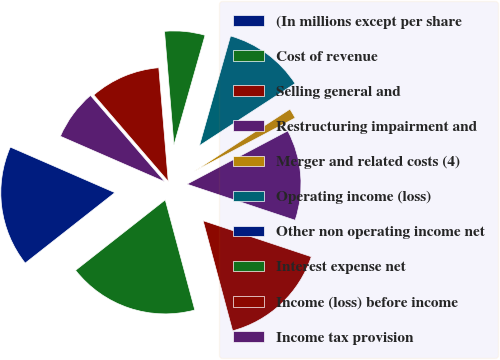Convert chart. <chart><loc_0><loc_0><loc_500><loc_500><pie_chart><fcel>(In millions except per share<fcel>Cost of revenue<fcel>Selling general and<fcel>Restructuring impairment and<fcel>Merger and related costs (4)<fcel>Operating income (loss)<fcel>Other non operating income net<fcel>Interest expense net<fcel>Income (loss) before income<fcel>Income tax provision<nl><fcel>17.14%<fcel>18.57%<fcel>15.71%<fcel>12.86%<fcel>1.43%<fcel>11.43%<fcel>0.0%<fcel>5.72%<fcel>10.0%<fcel>7.14%<nl></chart> 